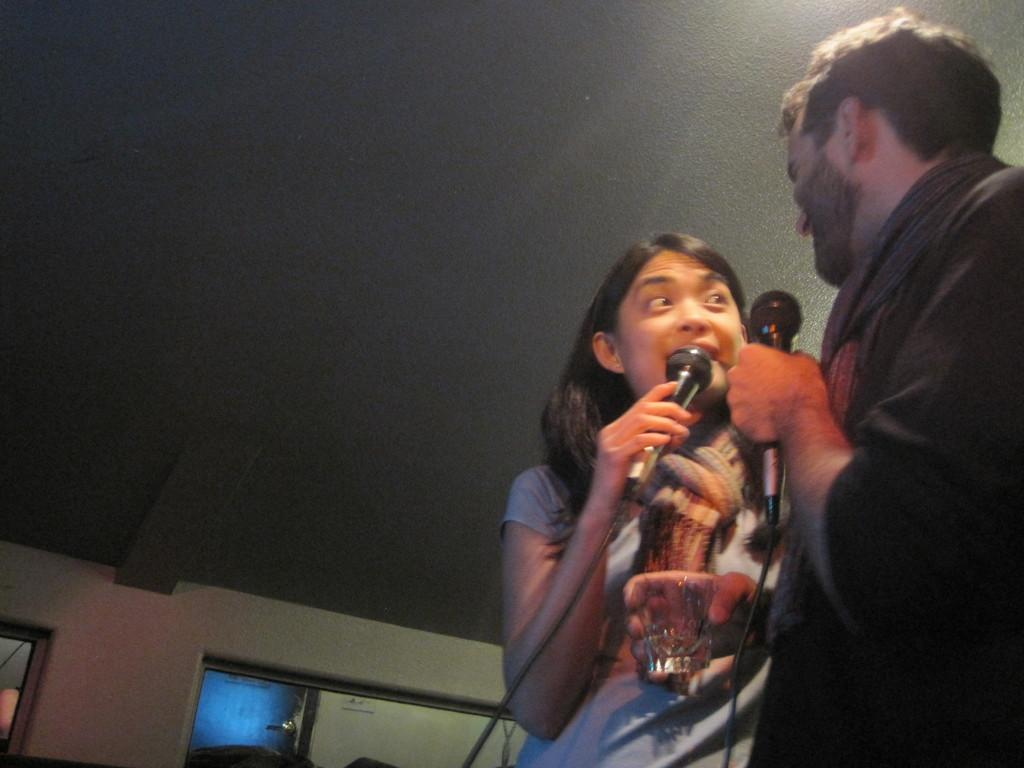How many people are in the image? There are two people in the image, a woman and a man. What are the woman and the man doing in the image? Both the woman and the man are standing and holding microphones in their hands. What else is the man holding in his hand? The man is holding a glass in his hand. What type of wheel can be seen in the image? There is no wheel present in the image. What type of cooking utensil is the woman using in the image? There is no cooking utensil or any indication of cooking in the image. 